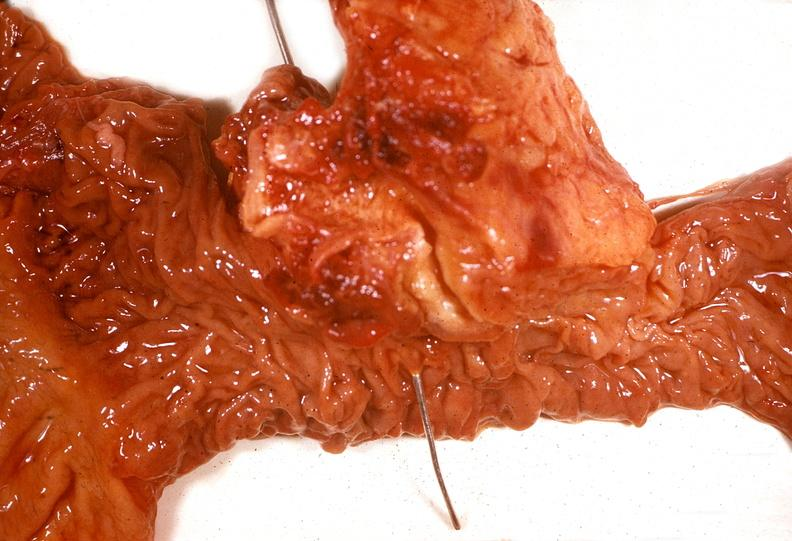what does this image show?
Answer the question using a single word or phrase. Adenocarcinoma 